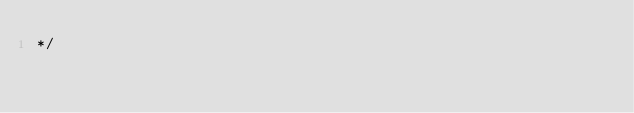Convert code to text. <code><loc_0><loc_0><loc_500><loc_500><_CSS_>*/</code> 